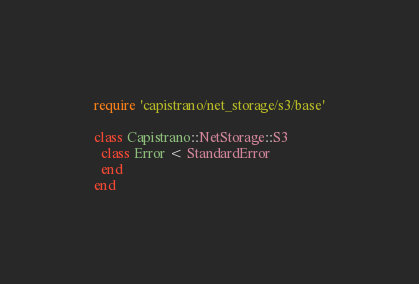<code> <loc_0><loc_0><loc_500><loc_500><_Ruby_>require 'capistrano/net_storage/s3/base'

class Capistrano::NetStorage::S3
  class Error < StandardError
  end
end
</code> 